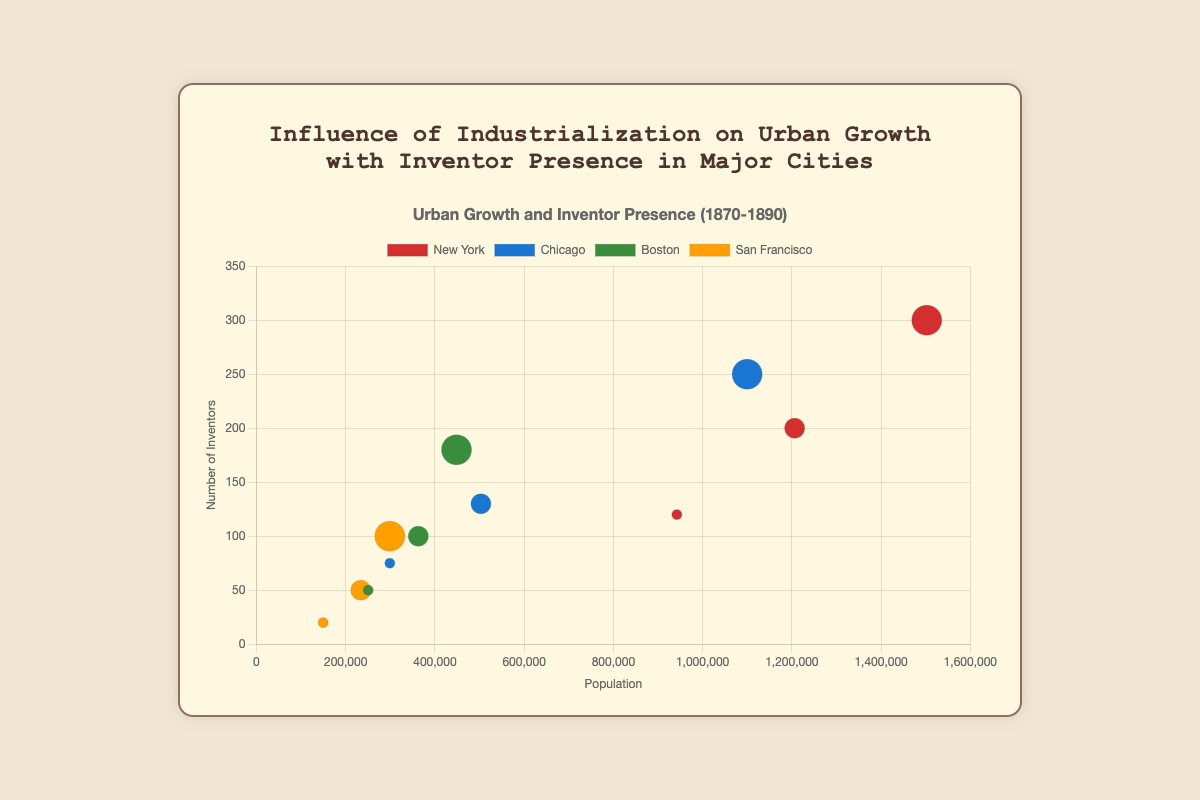What is the title of the chart? The title is displayed at the top center of the chart area. It provides an overview of what the chart represents.
Answer: Influence of Industrialization on Urban Growth with Inventor Presence in Major Cities What does the x-axis represent in the chart? The labels and unit on the x-axis indicate it represents the population of each city over the specified years.
Answer: Population Which city had the highest number of inventors in 1890? By looking at the y-axis and identifying the highest individual data point tagged with the year 1890 for each city group color, it's clear that New York had the highest number of inventors.
Answer: New York Which color is used to represent Boston in the chart? By matching the city names to their respective bubble colors in the legend, Boston's presence in the chart is represented with the color green.
Answer: Green How does the number of inventors in Chicago change between 1870 and 1890? Chicago’s data points for these years indicate 75 inventors in 1870 and 250 in 1890. Computing the difference, the number of inventors increased by 175.
Answer: Increased by 175 What is the shape of the relationship between population and number of inventors for New York from 1870 to 1890? Observing the trend of the red bubbles representing New York, there is a clear upward trend in both population and number of inventors over the years from 1870 to 1890.
Answer: Positive correlation On average, how many inventors were there in Boston over the three decades? Adding Boston’s inventor counts for 1870 (50), 1880 (100), and 1890 (180), the total is 330. Dividing by 3, the average is 110 inventors over the three decades.
Answer: 110 If a city shows a larger bubble size, what does it indicate about the year it represents? Each bubble size correlates proportionally to the year it represents, meaning larger bubbles correspond to later years within the time range of the study (1870-1890).
Answer: Later year within range Which city showed the least increase in population from 1870 to 1890? By inspecting the relative movement of bubbles along the x-axis (population axis) for all cities, San Francisco's population increase is the least from 1870 (149,473) to 1890 (298,997).
Answer: San Francisco In 1880, which city had the highest population and fewer inventors than New York? Comparing the bubbles tagged with 1880 across cities, while New York had the highest population, Chicago comes after with 503,185 population and fewer inventors (130) than New York's 200.
Answer: Chicago 